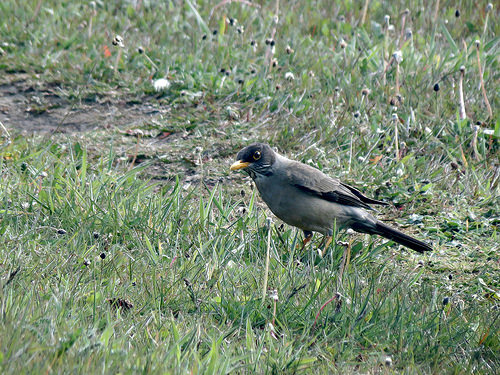<image>
Is the bird above the grass? No. The bird is not positioned above the grass. The vertical arrangement shows a different relationship. 